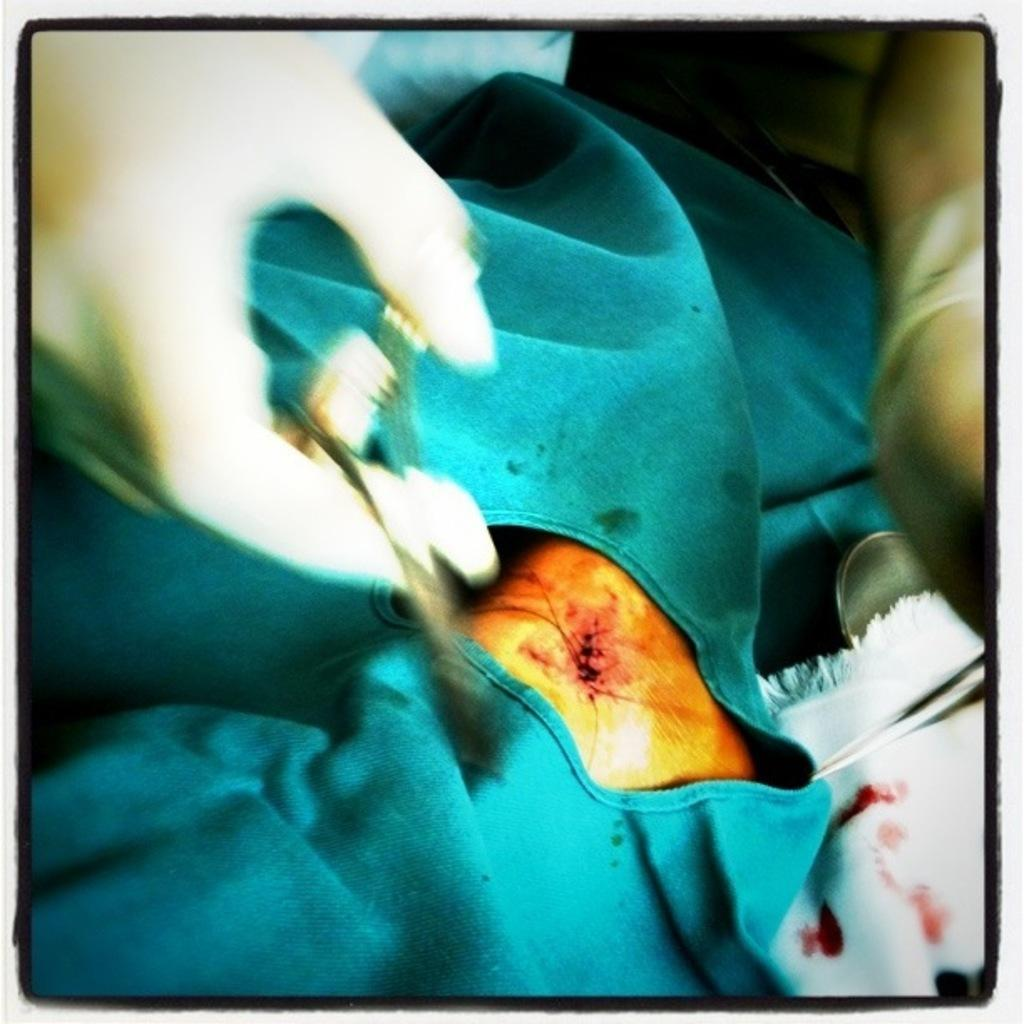What is the person holding in the image? The person is holding scissors in the image. What is in front of the person? There is a body in front of the person. What is covering the body? A green cloth is covering the body. What other cloth can be seen in the image? There is a white cloth visible in the image. What is unique about the white cloth? The white cloth has red dots on it. What type of cake is being prepared on the table in the image? There is no cake present in the image; it features a person holding scissors and a body covered by a green cloth. 